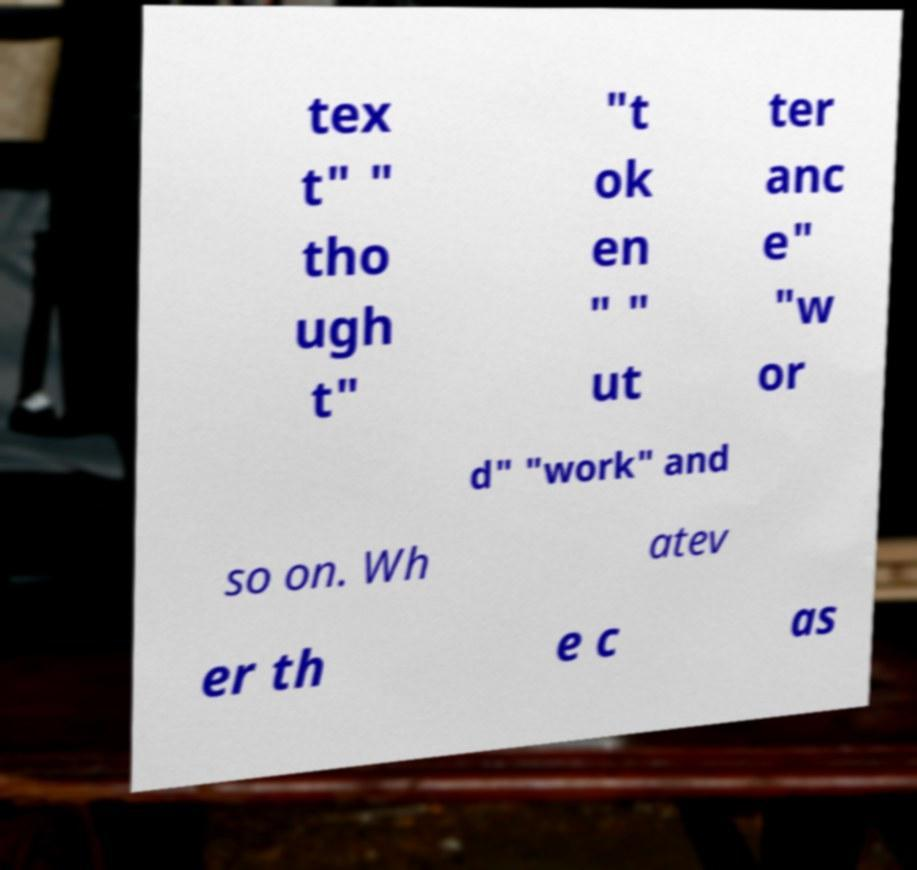Could you extract and type out the text from this image? tex t" " tho ugh t" "t ok en " " ut ter anc e" "w or d" "work" and so on. Wh atev er th e c as 